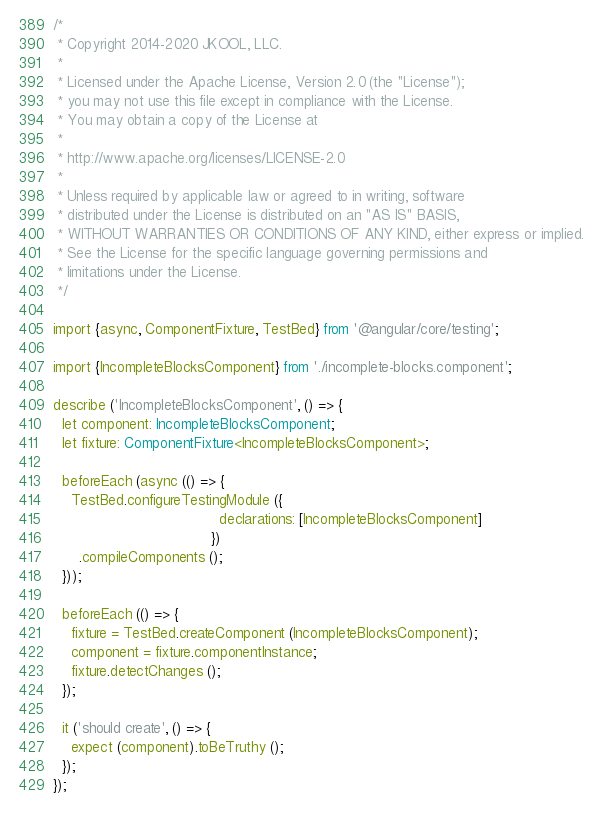Convert code to text. <code><loc_0><loc_0><loc_500><loc_500><_TypeScript_>/*
 * Copyright 2014-2020 JKOOL, LLC.
 *
 * Licensed under the Apache License, Version 2.0 (the "License");
 * you may not use this file except in compliance with the License.
 * You may obtain a copy of the License at
 *
 * http://www.apache.org/licenses/LICENSE-2.0
 *
 * Unless required by applicable law or agreed to in writing, software
 * distributed under the License is distributed on an "AS IS" BASIS,
 * WITHOUT WARRANTIES OR CONDITIONS OF ANY KIND, either express or implied.
 * See the License for the specific language governing permissions and
 * limitations under the License.
 */

import {async, ComponentFixture, TestBed} from '@angular/core/testing';

import {IncompleteBlocksComponent} from './incomplete-blocks.component';

describe ('IncompleteBlocksComponent', () => {
  let component: IncompleteBlocksComponent;
  let fixture: ComponentFixture<IncompleteBlocksComponent>;

  beforeEach (async (() => {
    TestBed.configureTestingModule ({
                                      declarations: [IncompleteBlocksComponent]
                                    })
      .compileComponents ();
  }));

  beforeEach (() => {
    fixture = TestBed.createComponent (IncompleteBlocksComponent);
    component = fixture.componentInstance;
    fixture.detectChanges ();
  });

  it ('should create', () => {
    expect (component).toBeTruthy ();
  });
});
</code> 